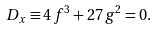Convert formula to latex. <formula><loc_0><loc_0><loc_500><loc_500>D _ { x } \equiv 4 \, f ^ { 3 } + 2 7 \, g ^ { 2 } = 0 .</formula> 